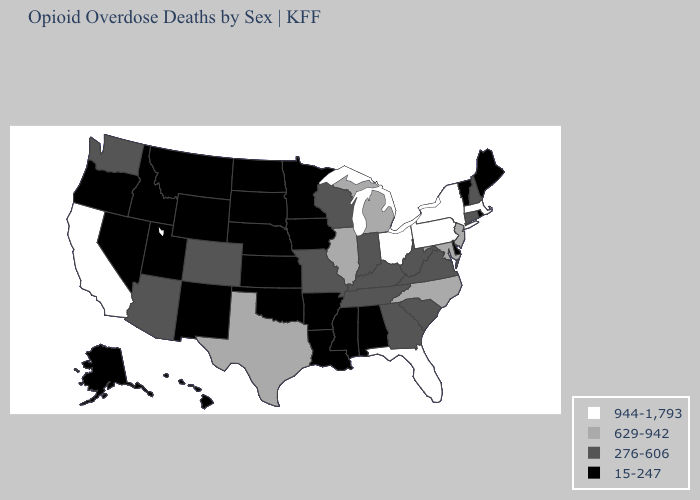Name the states that have a value in the range 944-1,793?
Concise answer only. California, Florida, Massachusetts, New York, Ohio, Pennsylvania. What is the lowest value in the USA?
Concise answer only. 15-247. What is the value of New York?
Quick response, please. 944-1,793. Does Connecticut have the highest value in the USA?
Be succinct. No. What is the value of New Hampshire?
Write a very short answer. 276-606. Name the states that have a value in the range 15-247?
Write a very short answer. Alabama, Alaska, Arkansas, Delaware, Hawaii, Idaho, Iowa, Kansas, Louisiana, Maine, Minnesota, Mississippi, Montana, Nebraska, Nevada, New Mexico, North Dakota, Oklahoma, Oregon, Rhode Island, South Dakota, Utah, Vermont, Wyoming. Does Oklahoma have the highest value in the South?
Concise answer only. No. Name the states that have a value in the range 276-606?
Quick response, please. Arizona, Colorado, Connecticut, Georgia, Indiana, Kentucky, Missouri, New Hampshire, South Carolina, Tennessee, Virginia, Washington, West Virginia, Wisconsin. Does the map have missing data?
Give a very brief answer. No. Which states have the highest value in the USA?
Keep it brief. California, Florida, Massachusetts, New York, Ohio, Pennsylvania. What is the lowest value in the USA?
Write a very short answer. 15-247. Which states have the lowest value in the MidWest?
Give a very brief answer. Iowa, Kansas, Minnesota, Nebraska, North Dakota, South Dakota. Does the map have missing data?
Be succinct. No. How many symbols are there in the legend?
Be succinct. 4. What is the value of New Jersey?
Short answer required. 629-942. 